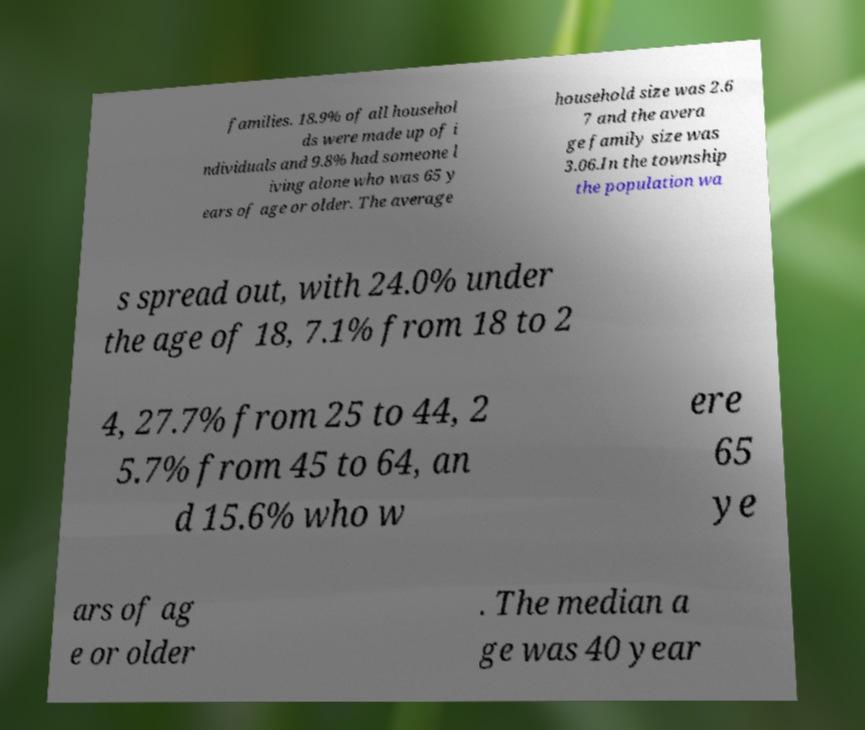What messages or text are displayed in this image? I need them in a readable, typed format. families. 18.9% of all househol ds were made up of i ndividuals and 9.8% had someone l iving alone who was 65 y ears of age or older. The average household size was 2.6 7 and the avera ge family size was 3.06.In the township the population wa s spread out, with 24.0% under the age of 18, 7.1% from 18 to 2 4, 27.7% from 25 to 44, 2 5.7% from 45 to 64, an d 15.6% who w ere 65 ye ars of ag e or older . The median a ge was 40 year 